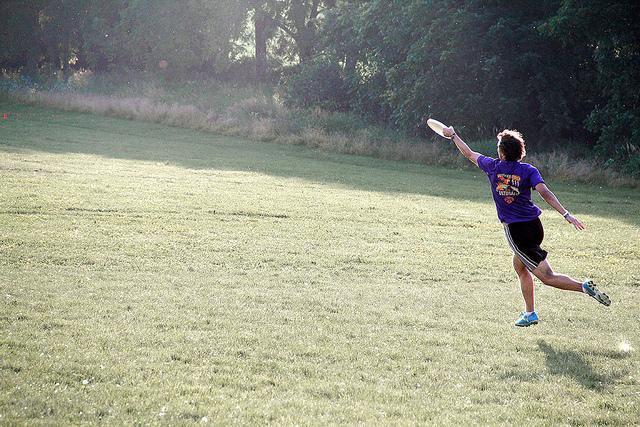How many glasses of orange juice are in the tray in the image?
Give a very brief answer. 0. 